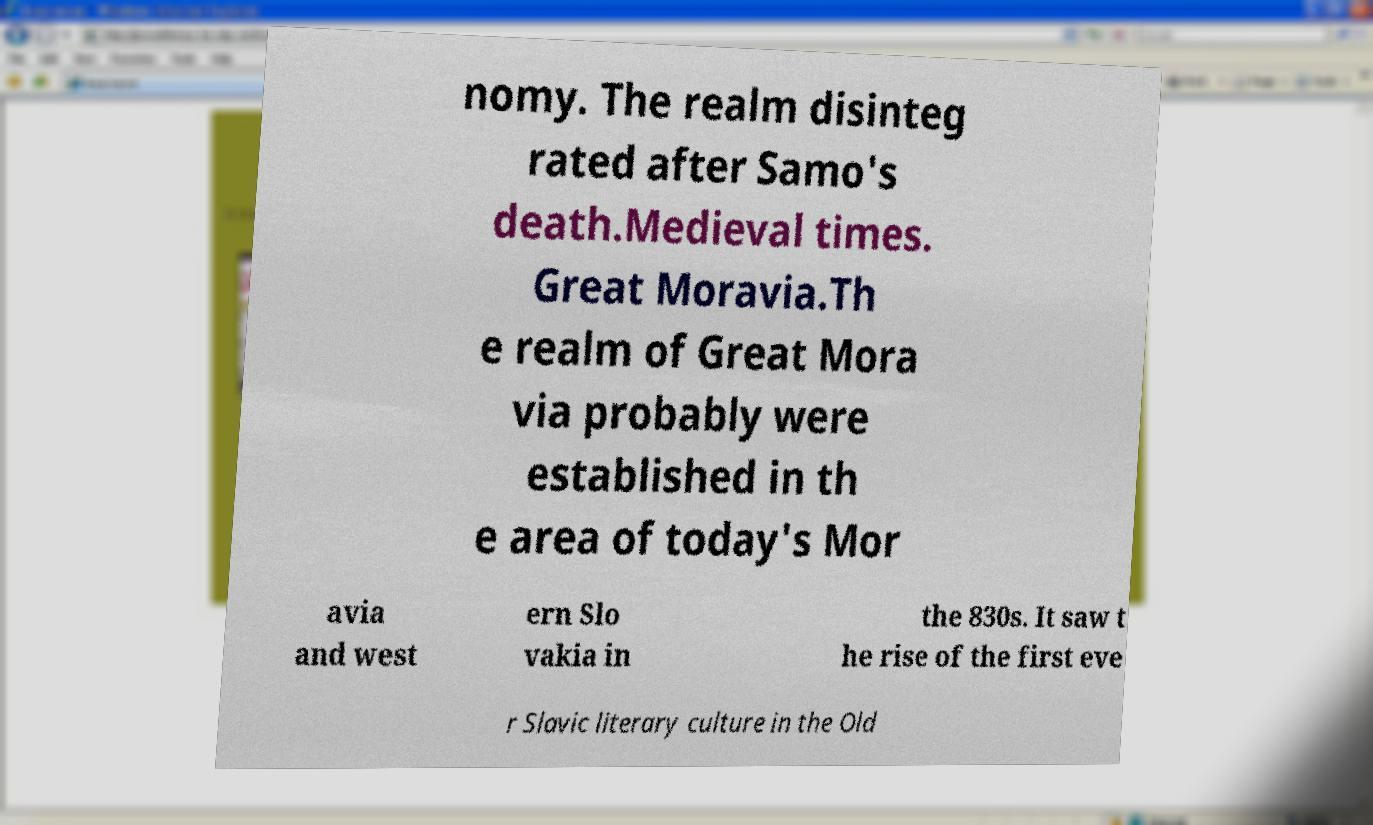Can you read and provide the text displayed in the image?This photo seems to have some interesting text. Can you extract and type it out for me? nomy. The realm disinteg rated after Samo's death.Medieval times. Great Moravia.Th e realm of Great Mora via probably were established in th e area of today's Mor avia and west ern Slo vakia in the 830s. It saw t he rise of the first eve r Slavic literary culture in the Old 